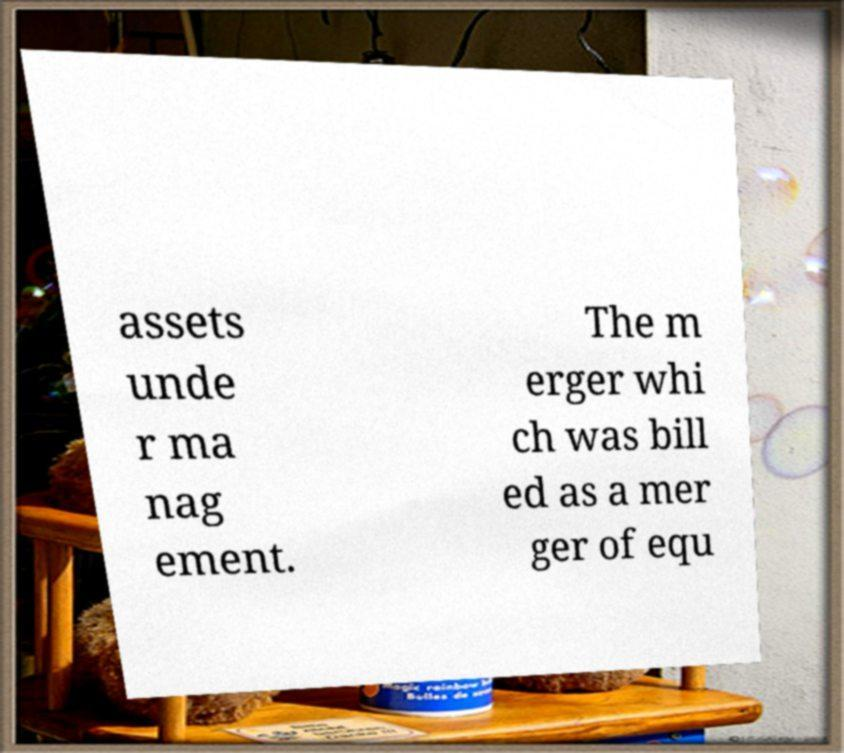Please read and relay the text visible in this image. What does it say? assets unde r ma nag ement. The m erger whi ch was bill ed as a mer ger of equ 